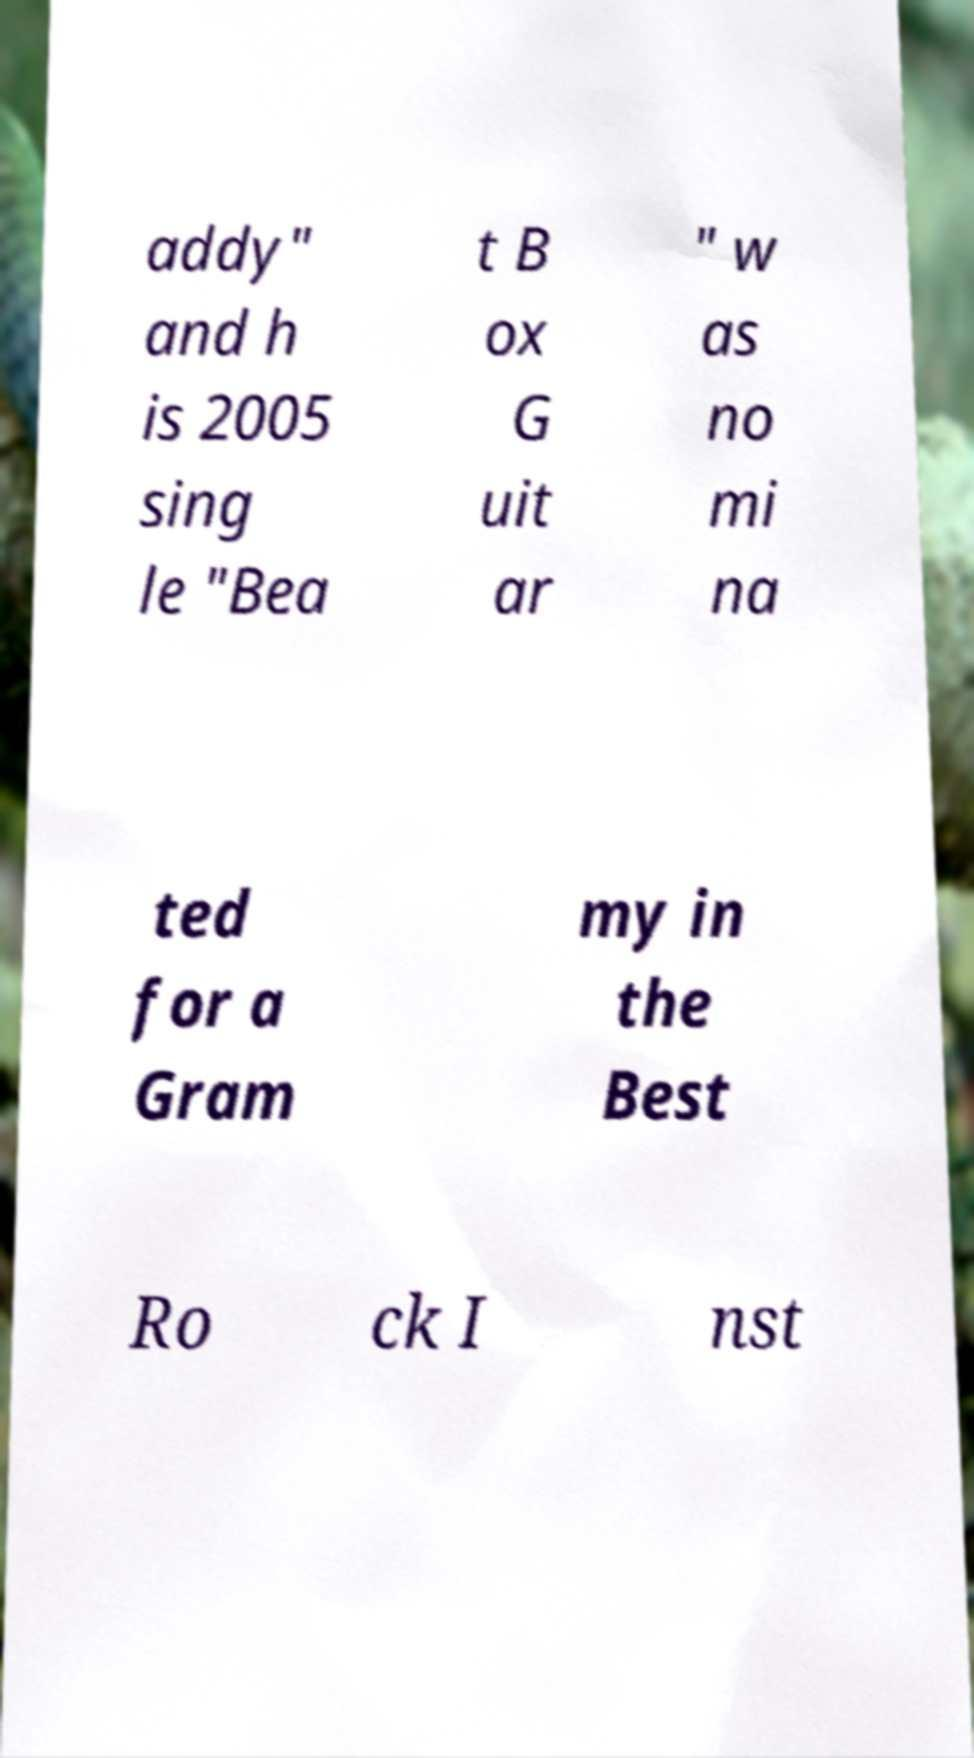Please read and relay the text visible in this image. What does it say? addy" and h is 2005 sing le "Bea t B ox G uit ar " w as no mi na ted for a Gram my in the Best Ro ck I nst 